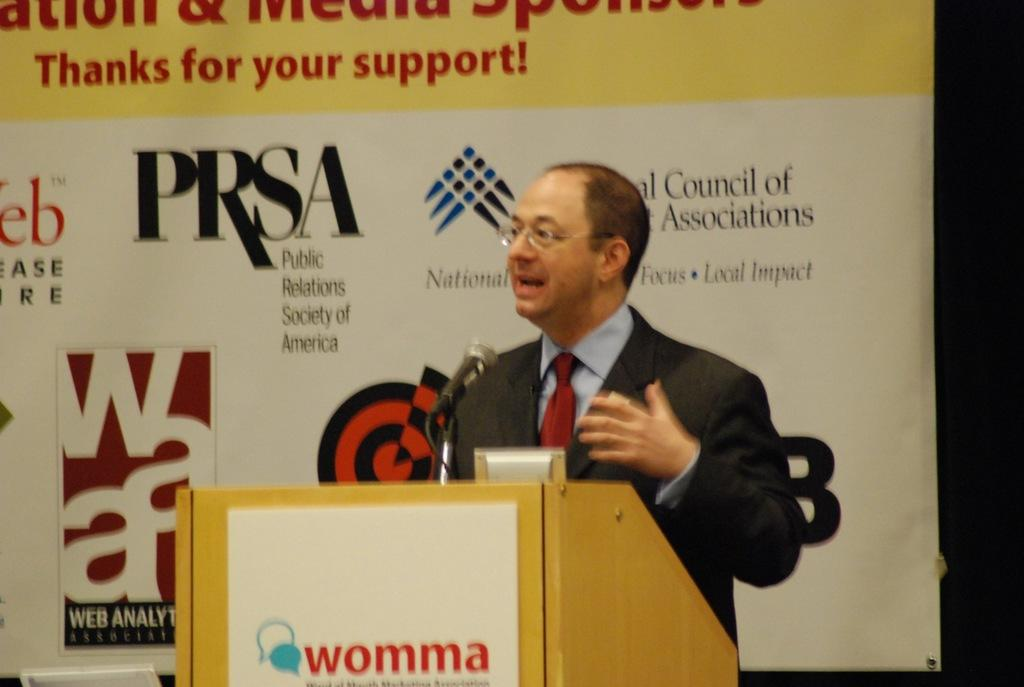Who or what is in the image? There is a person in the image. What is the person doing or where are they positioned? The person is standing in front of a desk. What object is on the desk? There is a microphone on the desk. What can be seen behind the desk? There is a poster behind the desk. What type of linen is draped over the microphone in the image? There is no linen draped over the microphone in the image; the microphone is on the desk without any additional coverings. 